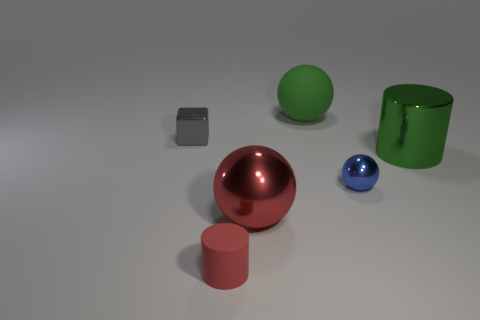Is the color of the sphere that is behind the small gray cube the same as the large cylinder? yes 